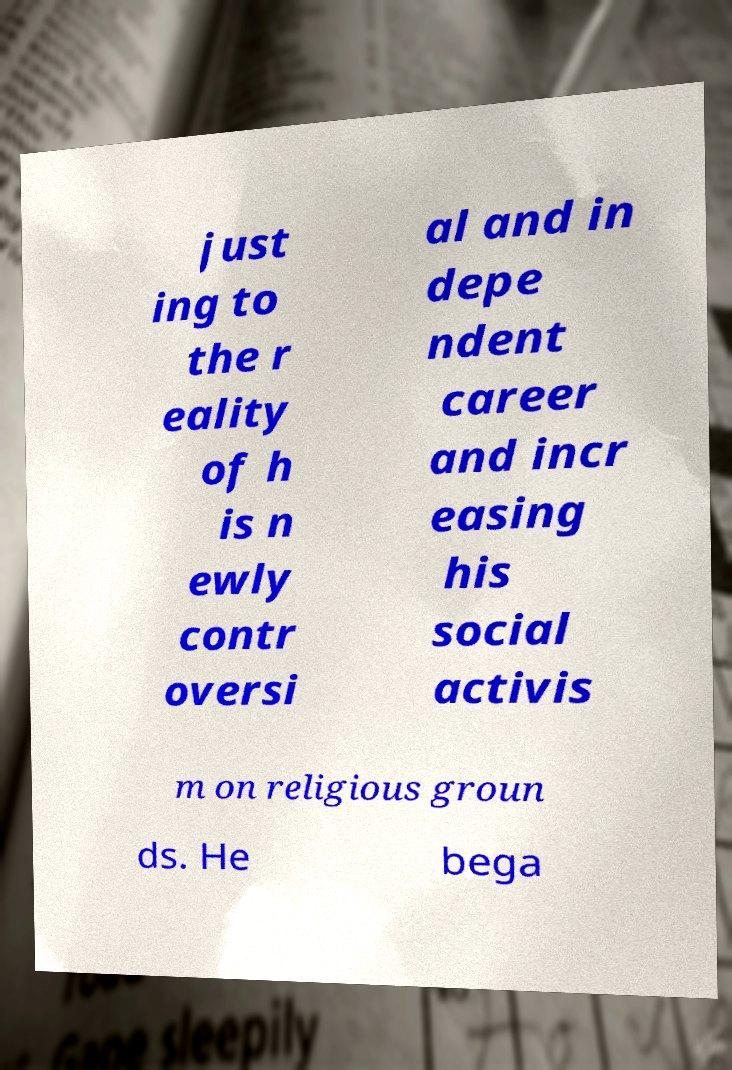Can you accurately transcribe the text from the provided image for me? just ing to the r eality of h is n ewly contr oversi al and in depe ndent career and incr easing his social activis m on religious groun ds. He bega 